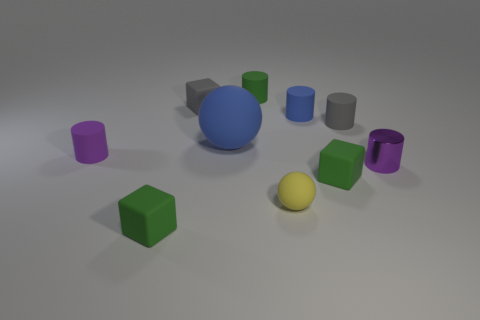Is there any other thing that has the same size as the blue rubber ball?
Provide a succinct answer. No. Are there any small purple cylinders on the right side of the small yellow object?
Provide a succinct answer. Yes. What is the color of the small matte block that is both in front of the metallic cylinder and on the left side of the tiny rubber sphere?
Provide a succinct answer. Green. Are there any blocks of the same color as the large ball?
Provide a short and direct response. No. Do the tiny gray cube that is on the left side of the yellow ball and the tiny object that is right of the small gray rubber cylinder have the same material?
Make the answer very short. No. There is a green cube that is on the left side of the green rubber cylinder; what size is it?
Provide a succinct answer. Small. What size is the yellow matte object?
Provide a succinct answer. Small. How big is the purple thing right of the green rubber cylinder that is behind the small green matte block on the left side of the tiny blue object?
Your response must be concise. Small. Is there a big sphere made of the same material as the tiny green cylinder?
Offer a very short reply. Yes. What is the shape of the metal thing?
Make the answer very short. Cylinder. 